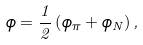<formula> <loc_0><loc_0><loc_500><loc_500>\phi = \frac { 1 } { 2 } \left ( \phi _ { \pi } + \phi _ { N } \right ) ,</formula> 